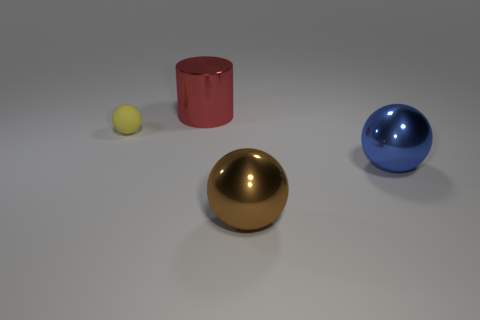What is the material of the big blue object?
Give a very brief answer. Metal. How big is the thing to the left of the object behind the sphere that is to the left of the cylinder?
Give a very brief answer. Small. How many rubber things are big brown balls or large objects?
Provide a succinct answer. 0. What size is the red metal cylinder?
Make the answer very short. Large. What number of objects are either cyan metallic spheres or metal objects in front of the small object?
Make the answer very short. 2. What number of other objects are the same color as the tiny rubber thing?
Provide a succinct answer. 0. There is a blue object; does it have the same size as the object behind the small matte thing?
Offer a terse response. Yes. Do the object on the left side of the red cylinder and the big red metallic cylinder have the same size?
Ensure brevity in your answer.  No. What number of other things are there of the same material as the yellow thing
Offer a very short reply. 0. Are there the same number of big metallic spheres that are on the right side of the small yellow thing and large balls that are to the left of the large blue sphere?
Your answer should be compact. No. 